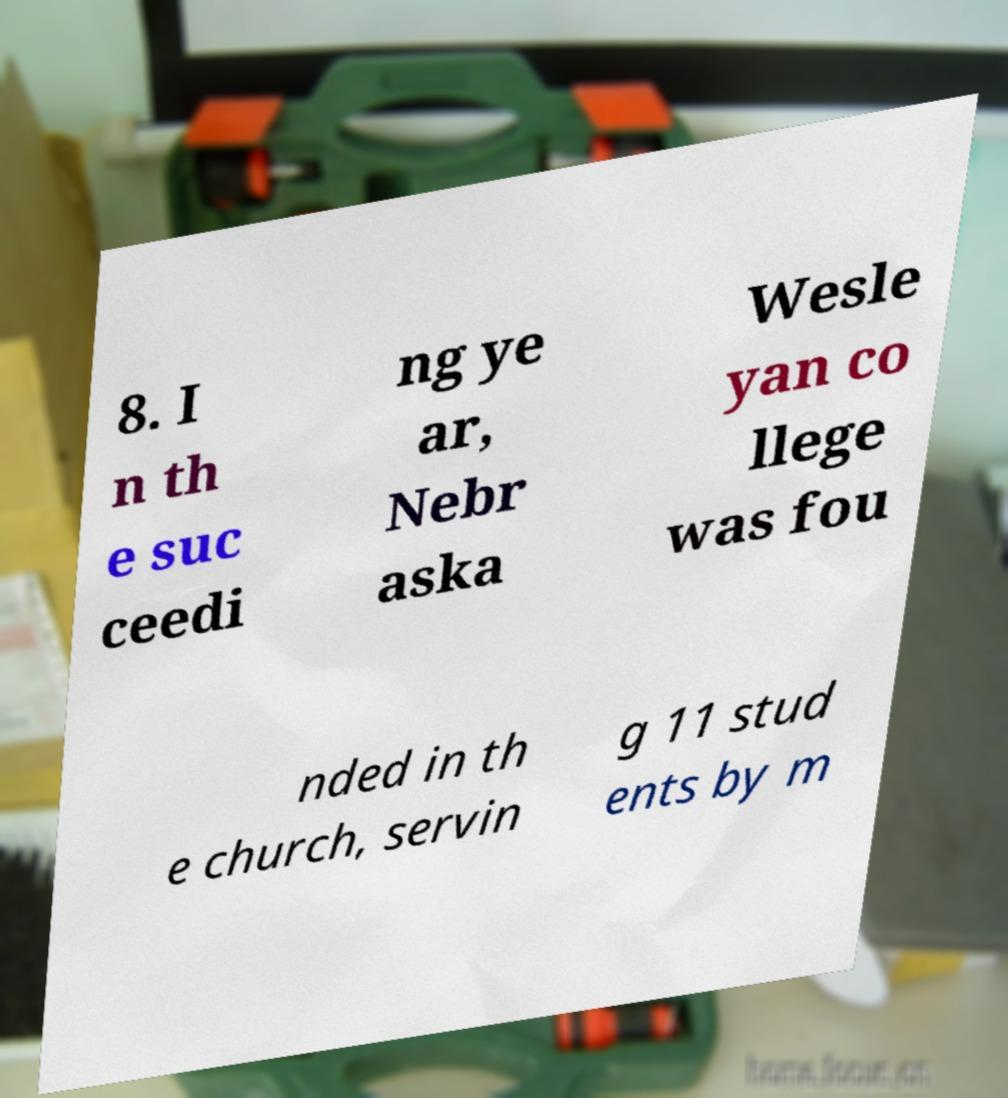For documentation purposes, I need the text within this image transcribed. Could you provide that? 8. I n th e suc ceedi ng ye ar, Nebr aska Wesle yan co llege was fou nded in th e church, servin g 11 stud ents by m 